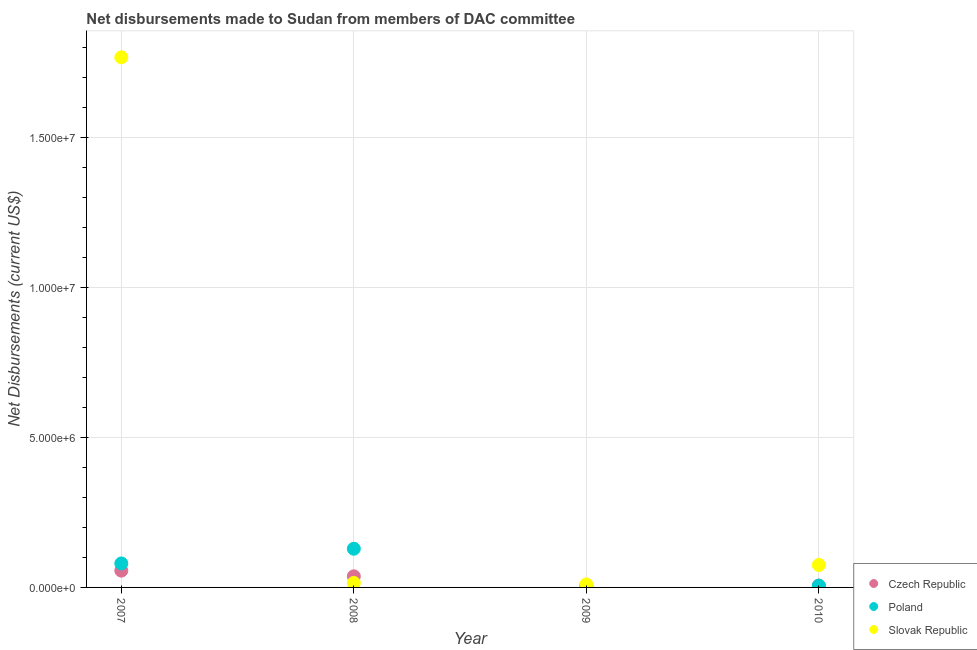Is the number of dotlines equal to the number of legend labels?
Ensure brevity in your answer.  Yes. What is the net disbursements made by slovak republic in 2009?
Ensure brevity in your answer.  1.00e+05. Across all years, what is the maximum net disbursements made by slovak republic?
Your response must be concise. 1.77e+07. Across all years, what is the minimum net disbursements made by slovak republic?
Keep it short and to the point. 1.00e+05. What is the total net disbursements made by slovak republic in the graph?
Provide a short and direct response. 1.87e+07. What is the difference between the net disbursements made by poland in 2009 and that in 2010?
Offer a terse response. -5.00e+04. What is the difference between the net disbursements made by slovak republic in 2007 and the net disbursements made by poland in 2008?
Keep it short and to the point. 1.64e+07. What is the average net disbursements made by slovak republic per year?
Make the answer very short. 4.67e+06. In the year 2007, what is the difference between the net disbursements made by poland and net disbursements made by slovak republic?
Ensure brevity in your answer.  -1.69e+07. What is the ratio of the net disbursements made by czech republic in 2007 to that in 2008?
Make the answer very short. 1.51. Is the net disbursements made by slovak republic in 2007 less than that in 2008?
Provide a short and direct response. No. Is the difference between the net disbursements made by poland in 2009 and 2010 greater than the difference between the net disbursements made by czech republic in 2009 and 2010?
Your answer should be compact. No. What is the difference between the highest and the lowest net disbursements made by czech republic?
Provide a succinct answer. 5.00e+05. Is the sum of the net disbursements made by slovak republic in 2007 and 2008 greater than the maximum net disbursements made by poland across all years?
Your answer should be compact. Yes. Is it the case that in every year, the sum of the net disbursements made by czech republic and net disbursements made by poland is greater than the net disbursements made by slovak republic?
Offer a very short reply. No. Does the net disbursements made by slovak republic monotonically increase over the years?
Your answer should be very brief. No. How many dotlines are there?
Your answer should be compact. 3. What is the difference between two consecutive major ticks on the Y-axis?
Keep it short and to the point. 5.00e+06. Does the graph contain any zero values?
Make the answer very short. No. Does the graph contain grids?
Make the answer very short. Yes. Where does the legend appear in the graph?
Offer a terse response. Bottom right. How many legend labels are there?
Provide a succinct answer. 3. What is the title of the graph?
Give a very brief answer. Net disbursements made to Sudan from members of DAC committee. What is the label or title of the Y-axis?
Provide a short and direct response. Net Disbursements (current US$). What is the Net Disbursements (current US$) of Czech Republic in 2007?
Your answer should be very brief. 5.60e+05. What is the Net Disbursements (current US$) in Slovak Republic in 2007?
Provide a succinct answer. 1.77e+07. What is the Net Disbursements (current US$) in Poland in 2008?
Your response must be concise. 1.29e+06. What is the Net Disbursements (current US$) of Slovak Republic in 2008?
Keep it short and to the point. 1.50e+05. What is the Net Disbursements (current US$) of Czech Republic in 2009?
Provide a succinct answer. 6.00e+04. What is the Net Disbursements (current US$) in Czech Republic in 2010?
Make the answer very short. 6.00e+04. What is the Net Disbursements (current US$) in Poland in 2010?
Offer a terse response. 6.00e+04. What is the Net Disbursements (current US$) of Slovak Republic in 2010?
Ensure brevity in your answer.  7.50e+05. Across all years, what is the maximum Net Disbursements (current US$) in Czech Republic?
Your answer should be very brief. 5.60e+05. Across all years, what is the maximum Net Disbursements (current US$) of Poland?
Offer a very short reply. 1.29e+06. Across all years, what is the maximum Net Disbursements (current US$) in Slovak Republic?
Offer a very short reply. 1.77e+07. Across all years, what is the minimum Net Disbursements (current US$) in Czech Republic?
Provide a short and direct response. 6.00e+04. Across all years, what is the minimum Net Disbursements (current US$) in Poland?
Offer a terse response. 10000. Across all years, what is the minimum Net Disbursements (current US$) of Slovak Republic?
Provide a succinct answer. 1.00e+05. What is the total Net Disbursements (current US$) in Czech Republic in the graph?
Your response must be concise. 1.05e+06. What is the total Net Disbursements (current US$) of Poland in the graph?
Your response must be concise. 2.16e+06. What is the total Net Disbursements (current US$) of Slovak Republic in the graph?
Ensure brevity in your answer.  1.87e+07. What is the difference between the Net Disbursements (current US$) in Poland in 2007 and that in 2008?
Your answer should be very brief. -4.90e+05. What is the difference between the Net Disbursements (current US$) of Slovak Republic in 2007 and that in 2008?
Keep it short and to the point. 1.75e+07. What is the difference between the Net Disbursements (current US$) of Poland in 2007 and that in 2009?
Offer a very short reply. 7.90e+05. What is the difference between the Net Disbursements (current US$) in Slovak Republic in 2007 and that in 2009?
Provide a succinct answer. 1.76e+07. What is the difference between the Net Disbursements (current US$) in Czech Republic in 2007 and that in 2010?
Offer a very short reply. 5.00e+05. What is the difference between the Net Disbursements (current US$) in Poland in 2007 and that in 2010?
Keep it short and to the point. 7.40e+05. What is the difference between the Net Disbursements (current US$) of Slovak Republic in 2007 and that in 2010?
Keep it short and to the point. 1.69e+07. What is the difference between the Net Disbursements (current US$) in Czech Republic in 2008 and that in 2009?
Your response must be concise. 3.10e+05. What is the difference between the Net Disbursements (current US$) in Poland in 2008 and that in 2009?
Make the answer very short. 1.28e+06. What is the difference between the Net Disbursements (current US$) of Czech Republic in 2008 and that in 2010?
Provide a short and direct response. 3.10e+05. What is the difference between the Net Disbursements (current US$) of Poland in 2008 and that in 2010?
Make the answer very short. 1.23e+06. What is the difference between the Net Disbursements (current US$) of Slovak Republic in 2008 and that in 2010?
Offer a terse response. -6.00e+05. What is the difference between the Net Disbursements (current US$) in Poland in 2009 and that in 2010?
Your answer should be very brief. -5.00e+04. What is the difference between the Net Disbursements (current US$) of Slovak Republic in 2009 and that in 2010?
Offer a very short reply. -6.50e+05. What is the difference between the Net Disbursements (current US$) in Czech Republic in 2007 and the Net Disbursements (current US$) in Poland in 2008?
Ensure brevity in your answer.  -7.30e+05. What is the difference between the Net Disbursements (current US$) in Czech Republic in 2007 and the Net Disbursements (current US$) in Slovak Republic in 2008?
Ensure brevity in your answer.  4.10e+05. What is the difference between the Net Disbursements (current US$) in Poland in 2007 and the Net Disbursements (current US$) in Slovak Republic in 2008?
Offer a very short reply. 6.50e+05. What is the difference between the Net Disbursements (current US$) in Czech Republic in 2007 and the Net Disbursements (current US$) in Poland in 2009?
Your answer should be compact. 5.50e+05. What is the difference between the Net Disbursements (current US$) in Czech Republic in 2007 and the Net Disbursements (current US$) in Slovak Republic in 2009?
Your answer should be very brief. 4.60e+05. What is the difference between the Net Disbursements (current US$) in Poland in 2007 and the Net Disbursements (current US$) in Slovak Republic in 2010?
Give a very brief answer. 5.00e+04. What is the difference between the Net Disbursements (current US$) of Czech Republic in 2008 and the Net Disbursements (current US$) of Poland in 2009?
Ensure brevity in your answer.  3.60e+05. What is the difference between the Net Disbursements (current US$) in Czech Republic in 2008 and the Net Disbursements (current US$) in Slovak Republic in 2009?
Ensure brevity in your answer.  2.70e+05. What is the difference between the Net Disbursements (current US$) of Poland in 2008 and the Net Disbursements (current US$) of Slovak Republic in 2009?
Your answer should be very brief. 1.19e+06. What is the difference between the Net Disbursements (current US$) of Czech Republic in 2008 and the Net Disbursements (current US$) of Poland in 2010?
Your response must be concise. 3.10e+05. What is the difference between the Net Disbursements (current US$) in Czech Republic in 2008 and the Net Disbursements (current US$) in Slovak Republic in 2010?
Your answer should be very brief. -3.80e+05. What is the difference between the Net Disbursements (current US$) of Poland in 2008 and the Net Disbursements (current US$) of Slovak Republic in 2010?
Your answer should be very brief. 5.40e+05. What is the difference between the Net Disbursements (current US$) in Czech Republic in 2009 and the Net Disbursements (current US$) in Slovak Republic in 2010?
Offer a very short reply. -6.90e+05. What is the difference between the Net Disbursements (current US$) of Poland in 2009 and the Net Disbursements (current US$) of Slovak Republic in 2010?
Offer a very short reply. -7.40e+05. What is the average Net Disbursements (current US$) in Czech Republic per year?
Make the answer very short. 2.62e+05. What is the average Net Disbursements (current US$) of Poland per year?
Make the answer very short. 5.40e+05. What is the average Net Disbursements (current US$) of Slovak Republic per year?
Your answer should be compact. 4.67e+06. In the year 2007, what is the difference between the Net Disbursements (current US$) of Czech Republic and Net Disbursements (current US$) of Slovak Republic?
Ensure brevity in your answer.  -1.71e+07. In the year 2007, what is the difference between the Net Disbursements (current US$) of Poland and Net Disbursements (current US$) of Slovak Republic?
Offer a terse response. -1.69e+07. In the year 2008, what is the difference between the Net Disbursements (current US$) in Czech Republic and Net Disbursements (current US$) in Poland?
Provide a succinct answer. -9.20e+05. In the year 2008, what is the difference between the Net Disbursements (current US$) in Poland and Net Disbursements (current US$) in Slovak Republic?
Your response must be concise. 1.14e+06. In the year 2009, what is the difference between the Net Disbursements (current US$) of Czech Republic and Net Disbursements (current US$) of Slovak Republic?
Keep it short and to the point. -4.00e+04. In the year 2010, what is the difference between the Net Disbursements (current US$) in Czech Republic and Net Disbursements (current US$) in Poland?
Provide a succinct answer. 0. In the year 2010, what is the difference between the Net Disbursements (current US$) of Czech Republic and Net Disbursements (current US$) of Slovak Republic?
Provide a short and direct response. -6.90e+05. In the year 2010, what is the difference between the Net Disbursements (current US$) in Poland and Net Disbursements (current US$) in Slovak Republic?
Your answer should be compact. -6.90e+05. What is the ratio of the Net Disbursements (current US$) in Czech Republic in 2007 to that in 2008?
Provide a short and direct response. 1.51. What is the ratio of the Net Disbursements (current US$) in Poland in 2007 to that in 2008?
Your answer should be very brief. 0.62. What is the ratio of the Net Disbursements (current US$) of Slovak Republic in 2007 to that in 2008?
Ensure brevity in your answer.  117.87. What is the ratio of the Net Disbursements (current US$) of Czech Republic in 2007 to that in 2009?
Ensure brevity in your answer.  9.33. What is the ratio of the Net Disbursements (current US$) in Slovak Republic in 2007 to that in 2009?
Offer a terse response. 176.8. What is the ratio of the Net Disbursements (current US$) of Czech Republic in 2007 to that in 2010?
Make the answer very short. 9.33. What is the ratio of the Net Disbursements (current US$) of Poland in 2007 to that in 2010?
Offer a very short reply. 13.33. What is the ratio of the Net Disbursements (current US$) of Slovak Republic in 2007 to that in 2010?
Provide a succinct answer. 23.57. What is the ratio of the Net Disbursements (current US$) of Czech Republic in 2008 to that in 2009?
Your answer should be very brief. 6.17. What is the ratio of the Net Disbursements (current US$) in Poland in 2008 to that in 2009?
Ensure brevity in your answer.  129. What is the ratio of the Net Disbursements (current US$) in Czech Republic in 2008 to that in 2010?
Make the answer very short. 6.17. What is the ratio of the Net Disbursements (current US$) of Poland in 2008 to that in 2010?
Offer a terse response. 21.5. What is the ratio of the Net Disbursements (current US$) of Slovak Republic in 2008 to that in 2010?
Give a very brief answer. 0.2. What is the ratio of the Net Disbursements (current US$) in Czech Republic in 2009 to that in 2010?
Ensure brevity in your answer.  1. What is the ratio of the Net Disbursements (current US$) in Poland in 2009 to that in 2010?
Offer a very short reply. 0.17. What is the ratio of the Net Disbursements (current US$) in Slovak Republic in 2009 to that in 2010?
Your response must be concise. 0.13. What is the difference between the highest and the second highest Net Disbursements (current US$) of Slovak Republic?
Offer a very short reply. 1.69e+07. What is the difference between the highest and the lowest Net Disbursements (current US$) in Czech Republic?
Your answer should be compact. 5.00e+05. What is the difference between the highest and the lowest Net Disbursements (current US$) of Poland?
Offer a very short reply. 1.28e+06. What is the difference between the highest and the lowest Net Disbursements (current US$) in Slovak Republic?
Offer a very short reply. 1.76e+07. 